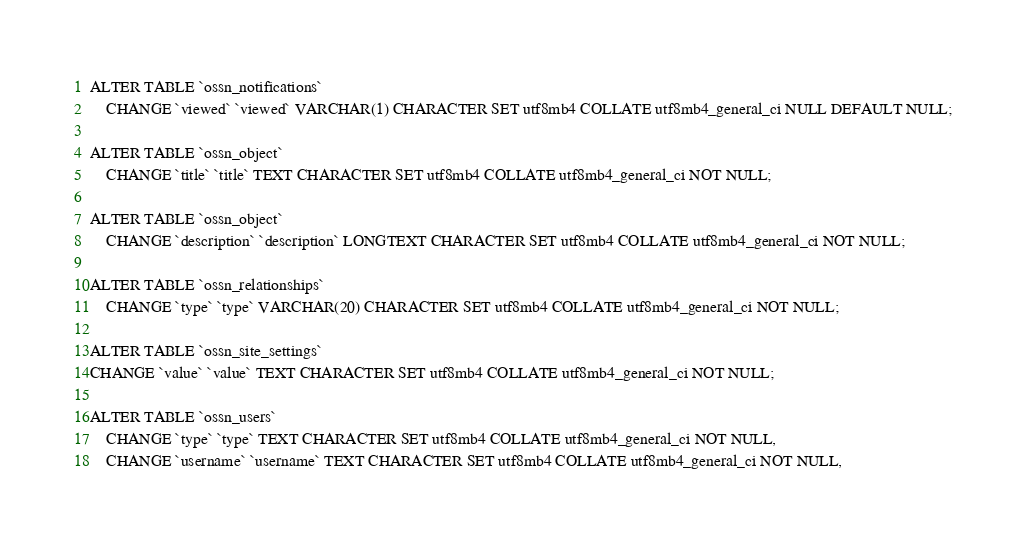<code> <loc_0><loc_0><loc_500><loc_500><_PHP_>ALTER TABLE `ossn_notifications` 
	CHANGE `viewed` `viewed` VARCHAR(1) CHARACTER SET utf8mb4 COLLATE utf8mb4_general_ci NULL DEFAULT NULL;
	
ALTER TABLE `ossn_object` 
	CHANGE `title` `title` TEXT CHARACTER SET utf8mb4 COLLATE utf8mb4_general_ci NOT NULL;

ALTER TABLE `ossn_object` 
	CHANGE `description` `description` LONGTEXT CHARACTER SET utf8mb4 COLLATE utf8mb4_general_ci NOT NULL;
	
ALTER TABLE `ossn_relationships` 
	CHANGE `type` `type` VARCHAR(20) CHARACTER SET utf8mb4 COLLATE utf8mb4_general_ci NOT NULL;
	
ALTER TABLE `ossn_site_settings` 
CHANGE `value` `value` TEXT CHARACTER SET utf8mb4 COLLATE utf8mb4_general_ci NOT NULL;

ALTER TABLE `ossn_users` 
	CHANGE `type` `type` TEXT CHARACTER SET utf8mb4 COLLATE utf8mb4_general_ci NOT NULL,
	CHANGE `username` `username` TEXT CHARACTER SET utf8mb4 COLLATE utf8mb4_general_ci NOT NULL,</code> 